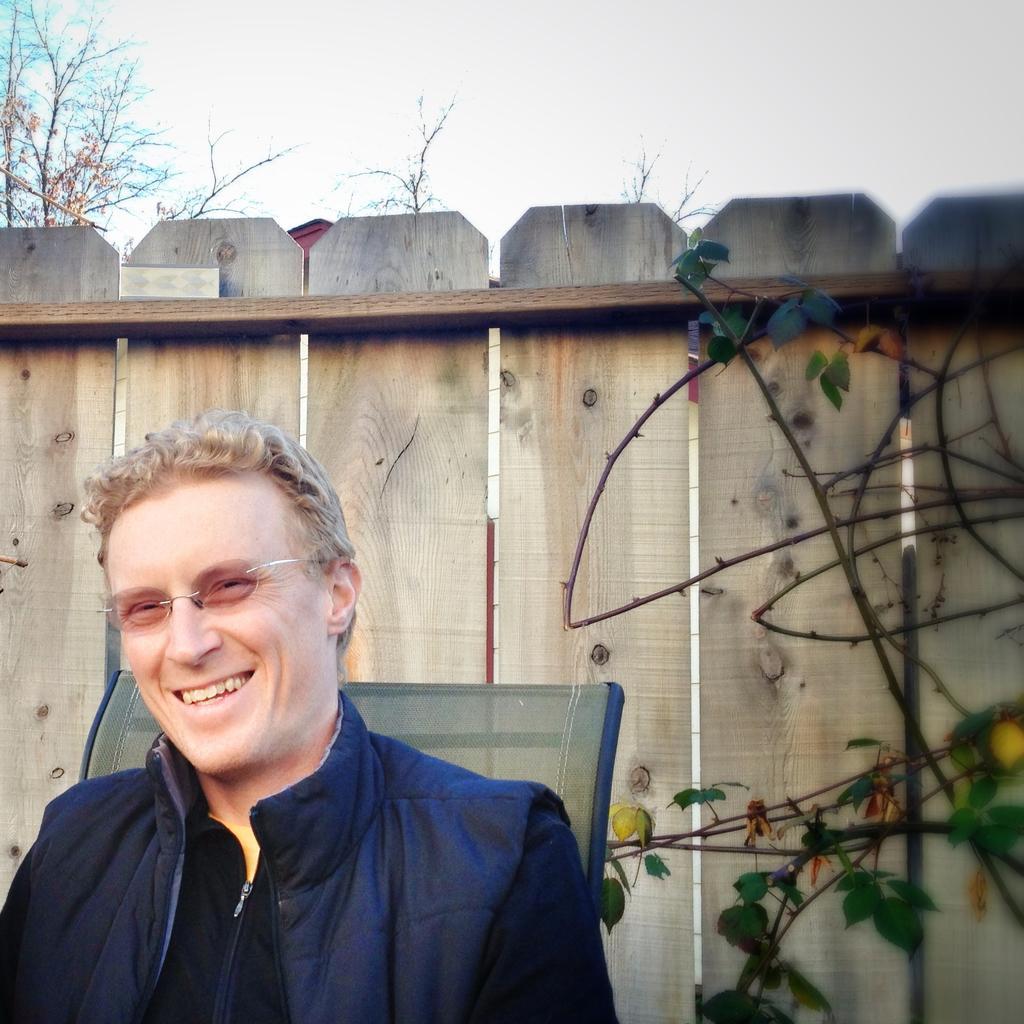Can you describe this image briefly? In this picture I can see a man sitting in front and I see that he is smiling. Behind him I can see few plants and wooden fencing. In the background I can see the sky and few trees. 